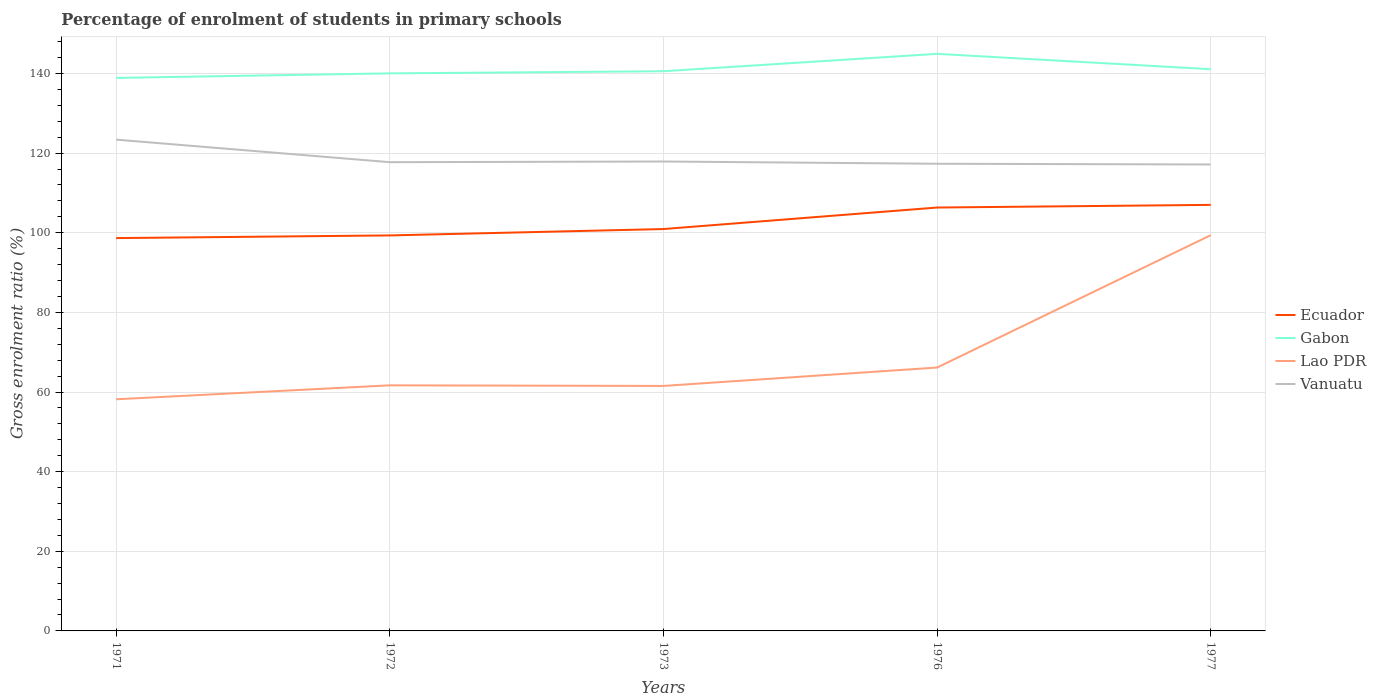How many different coloured lines are there?
Your answer should be very brief. 4. Across all years, what is the maximum percentage of students enrolled in primary schools in Ecuador?
Give a very brief answer. 98.66. What is the total percentage of students enrolled in primary schools in Gabon in the graph?
Offer a terse response. -6.04. What is the difference between the highest and the second highest percentage of students enrolled in primary schools in Vanuatu?
Offer a very short reply. 6.24. What is the difference between the highest and the lowest percentage of students enrolled in primary schools in Gabon?
Ensure brevity in your answer.  1. Is the percentage of students enrolled in primary schools in Gabon strictly greater than the percentage of students enrolled in primary schools in Vanuatu over the years?
Your answer should be very brief. No. How many years are there in the graph?
Make the answer very short. 5. What is the difference between two consecutive major ticks on the Y-axis?
Your response must be concise. 20. Does the graph contain grids?
Make the answer very short. Yes. What is the title of the graph?
Your answer should be compact. Percentage of enrolment of students in primary schools. What is the label or title of the X-axis?
Your response must be concise. Years. What is the label or title of the Y-axis?
Provide a succinct answer. Gross enrolment ratio (%). What is the Gross enrolment ratio (%) in Ecuador in 1971?
Offer a terse response. 98.66. What is the Gross enrolment ratio (%) in Gabon in 1971?
Your response must be concise. 138.89. What is the Gross enrolment ratio (%) in Lao PDR in 1971?
Provide a succinct answer. 58.17. What is the Gross enrolment ratio (%) in Vanuatu in 1971?
Your response must be concise. 123.39. What is the Gross enrolment ratio (%) of Ecuador in 1972?
Give a very brief answer. 99.33. What is the Gross enrolment ratio (%) of Gabon in 1972?
Your response must be concise. 140.03. What is the Gross enrolment ratio (%) of Lao PDR in 1972?
Your response must be concise. 61.68. What is the Gross enrolment ratio (%) in Vanuatu in 1972?
Ensure brevity in your answer.  117.72. What is the Gross enrolment ratio (%) in Ecuador in 1973?
Make the answer very short. 100.93. What is the Gross enrolment ratio (%) in Gabon in 1973?
Your answer should be compact. 140.56. What is the Gross enrolment ratio (%) in Lao PDR in 1973?
Your response must be concise. 61.53. What is the Gross enrolment ratio (%) of Vanuatu in 1973?
Offer a terse response. 117.89. What is the Gross enrolment ratio (%) of Ecuador in 1976?
Provide a succinct answer. 106.33. What is the Gross enrolment ratio (%) of Gabon in 1976?
Make the answer very short. 144.93. What is the Gross enrolment ratio (%) in Lao PDR in 1976?
Provide a short and direct response. 66.15. What is the Gross enrolment ratio (%) in Vanuatu in 1976?
Your answer should be very brief. 117.33. What is the Gross enrolment ratio (%) of Ecuador in 1977?
Offer a terse response. 107. What is the Gross enrolment ratio (%) in Gabon in 1977?
Provide a short and direct response. 141.07. What is the Gross enrolment ratio (%) of Lao PDR in 1977?
Offer a terse response. 99.39. What is the Gross enrolment ratio (%) in Vanuatu in 1977?
Give a very brief answer. 117.14. Across all years, what is the maximum Gross enrolment ratio (%) in Ecuador?
Offer a terse response. 107. Across all years, what is the maximum Gross enrolment ratio (%) in Gabon?
Provide a succinct answer. 144.93. Across all years, what is the maximum Gross enrolment ratio (%) in Lao PDR?
Your answer should be compact. 99.39. Across all years, what is the maximum Gross enrolment ratio (%) in Vanuatu?
Offer a terse response. 123.39. Across all years, what is the minimum Gross enrolment ratio (%) in Ecuador?
Keep it short and to the point. 98.66. Across all years, what is the minimum Gross enrolment ratio (%) in Gabon?
Offer a very short reply. 138.89. Across all years, what is the minimum Gross enrolment ratio (%) in Lao PDR?
Keep it short and to the point. 58.17. Across all years, what is the minimum Gross enrolment ratio (%) in Vanuatu?
Make the answer very short. 117.14. What is the total Gross enrolment ratio (%) in Ecuador in the graph?
Ensure brevity in your answer.  512.24. What is the total Gross enrolment ratio (%) in Gabon in the graph?
Your response must be concise. 705.48. What is the total Gross enrolment ratio (%) of Lao PDR in the graph?
Your response must be concise. 346.92. What is the total Gross enrolment ratio (%) of Vanuatu in the graph?
Offer a terse response. 593.47. What is the difference between the Gross enrolment ratio (%) in Ecuador in 1971 and that in 1972?
Offer a very short reply. -0.67. What is the difference between the Gross enrolment ratio (%) of Gabon in 1971 and that in 1972?
Provide a short and direct response. -1.14. What is the difference between the Gross enrolment ratio (%) of Lao PDR in 1971 and that in 1972?
Give a very brief answer. -3.51. What is the difference between the Gross enrolment ratio (%) in Vanuatu in 1971 and that in 1972?
Your answer should be very brief. 5.67. What is the difference between the Gross enrolment ratio (%) of Ecuador in 1971 and that in 1973?
Your answer should be very brief. -2.27. What is the difference between the Gross enrolment ratio (%) of Gabon in 1971 and that in 1973?
Provide a succinct answer. -1.68. What is the difference between the Gross enrolment ratio (%) of Lao PDR in 1971 and that in 1973?
Offer a very short reply. -3.35. What is the difference between the Gross enrolment ratio (%) in Vanuatu in 1971 and that in 1973?
Make the answer very short. 5.49. What is the difference between the Gross enrolment ratio (%) of Ecuador in 1971 and that in 1976?
Your response must be concise. -7.68. What is the difference between the Gross enrolment ratio (%) of Gabon in 1971 and that in 1976?
Give a very brief answer. -6.04. What is the difference between the Gross enrolment ratio (%) in Lao PDR in 1971 and that in 1976?
Keep it short and to the point. -7.97. What is the difference between the Gross enrolment ratio (%) of Vanuatu in 1971 and that in 1976?
Give a very brief answer. 6.06. What is the difference between the Gross enrolment ratio (%) in Ecuador in 1971 and that in 1977?
Offer a terse response. -8.34. What is the difference between the Gross enrolment ratio (%) of Gabon in 1971 and that in 1977?
Keep it short and to the point. -2.18. What is the difference between the Gross enrolment ratio (%) in Lao PDR in 1971 and that in 1977?
Keep it short and to the point. -41.21. What is the difference between the Gross enrolment ratio (%) in Vanuatu in 1971 and that in 1977?
Your answer should be very brief. 6.24. What is the difference between the Gross enrolment ratio (%) of Ecuador in 1972 and that in 1973?
Give a very brief answer. -1.6. What is the difference between the Gross enrolment ratio (%) of Gabon in 1972 and that in 1973?
Offer a very short reply. -0.54. What is the difference between the Gross enrolment ratio (%) in Lao PDR in 1972 and that in 1973?
Ensure brevity in your answer.  0.15. What is the difference between the Gross enrolment ratio (%) of Vanuatu in 1972 and that in 1973?
Offer a very short reply. -0.17. What is the difference between the Gross enrolment ratio (%) in Ecuador in 1972 and that in 1976?
Make the answer very short. -7.01. What is the difference between the Gross enrolment ratio (%) of Gabon in 1972 and that in 1976?
Provide a succinct answer. -4.9. What is the difference between the Gross enrolment ratio (%) in Lao PDR in 1972 and that in 1976?
Ensure brevity in your answer.  -4.47. What is the difference between the Gross enrolment ratio (%) in Vanuatu in 1972 and that in 1976?
Offer a very short reply. 0.39. What is the difference between the Gross enrolment ratio (%) in Ecuador in 1972 and that in 1977?
Offer a terse response. -7.67. What is the difference between the Gross enrolment ratio (%) of Gabon in 1972 and that in 1977?
Your answer should be compact. -1.04. What is the difference between the Gross enrolment ratio (%) of Lao PDR in 1972 and that in 1977?
Your answer should be very brief. -37.71. What is the difference between the Gross enrolment ratio (%) of Vanuatu in 1972 and that in 1977?
Provide a short and direct response. 0.57. What is the difference between the Gross enrolment ratio (%) of Ecuador in 1973 and that in 1976?
Ensure brevity in your answer.  -5.4. What is the difference between the Gross enrolment ratio (%) of Gabon in 1973 and that in 1976?
Your answer should be very brief. -4.37. What is the difference between the Gross enrolment ratio (%) in Lao PDR in 1973 and that in 1976?
Your answer should be very brief. -4.62. What is the difference between the Gross enrolment ratio (%) of Vanuatu in 1973 and that in 1976?
Keep it short and to the point. 0.57. What is the difference between the Gross enrolment ratio (%) of Ecuador in 1973 and that in 1977?
Keep it short and to the point. -6.07. What is the difference between the Gross enrolment ratio (%) in Gabon in 1973 and that in 1977?
Offer a very short reply. -0.51. What is the difference between the Gross enrolment ratio (%) in Lao PDR in 1973 and that in 1977?
Provide a short and direct response. -37.86. What is the difference between the Gross enrolment ratio (%) of Vanuatu in 1973 and that in 1977?
Provide a short and direct response. 0.75. What is the difference between the Gross enrolment ratio (%) of Ecuador in 1976 and that in 1977?
Offer a terse response. -0.67. What is the difference between the Gross enrolment ratio (%) of Gabon in 1976 and that in 1977?
Give a very brief answer. 3.86. What is the difference between the Gross enrolment ratio (%) in Lao PDR in 1976 and that in 1977?
Offer a terse response. -33.24. What is the difference between the Gross enrolment ratio (%) of Vanuatu in 1976 and that in 1977?
Your answer should be very brief. 0.18. What is the difference between the Gross enrolment ratio (%) in Ecuador in 1971 and the Gross enrolment ratio (%) in Gabon in 1972?
Ensure brevity in your answer.  -41.37. What is the difference between the Gross enrolment ratio (%) of Ecuador in 1971 and the Gross enrolment ratio (%) of Lao PDR in 1972?
Provide a succinct answer. 36.98. What is the difference between the Gross enrolment ratio (%) of Ecuador in 1971 and the Gross enrolment ratio (%) of Vanuatu in 1972?
Provide a succinct answer. -19.06. What is the difference between the Gross enrolment ratio (%) in Gabon in 1971 and the Gross enrolment ratio (%) in Lao PDR in 1972?
Provide a short and direct response. 77.21. What is the difference between the Gross enrolment ratio (%) in Gabon in 1971 and the Gross enrolment ratio (%) in Vanuatu in 1972?
Keep it short and to the point. 21.17. What is the difference between the Gross enrolment ratio (%) of Lao PDR in 1971 and the Gross enrolment ratio (%) of Vanuatu in 1972?
Give a very brief answer. -59.54. What is the difference between the Gross enrolment ratio (%) of Ecuador in 1971 and the Gross enrolment ratio (%) of Gabon in 1973?
Your answer should be compact. -41.91. What is the difference between the Gross enrolment ratio (%) of Ecuador in 1971 and the Gross enrolment ratio (%) of Lao PDR in 1973?
Provide a short and direct response. 37.13. What is the difference between the Gross enrolment ratio (%) in Ecuador in 1971 and the Gross enrolment ratio (%) in Vanuatu in 1973?
Keep it short and to the point. -19.24. What is the difference between the Gross enrolment ratio (%) in Gabon in 1971 and the Gross enrolment ratio (%) in Lao PDR in 1973?
Ensure brevity in your answer.  77.36. What is the difference between the Gross enrolment ratio (%) in Gabon in 1971 and the Gross enrolment ratio (%) in Vanuatu in 1973?
Offer a very short reply. 20.99. What is the difference between the Gross enrolment ratio (%) in Lao PDR in 1971 and the Gross enrolment ratio (%) in Vanuatu in 1973?
Give a very brief answer. -59.72. What is the difference between the Gross enrolment ratio (%) of Ecuador in 1971 and the Gross enrolment ratio (%) of Gabon in 1976?
Your response must be concise. -46.27. What is the difference between the Gross enrolment ratio (%) of Ecuador in 1971 and the Gross enrolment ratio (%) of Lao PDR in 1976?
Give a very brief answer. 32.51. What is the difference between the Gross enrolment ratio (%) in Ecuador in 1971 and the Gross enrolment ratio (%) in Vanuatu in 1976?
Your answer should be compact. -18.67. What is the difference between the Gross enrolment ratio (%) in Gabon in 1971 and the Gross enrolment ratio (%) in Lao PDR in 1976?
Offer a terse response. 72.74. What is the difference between the Gross enrolment ratio (%) of Gabon in 1971 and the Gross enrolment ratio (%) of Vanuatu in 1976?
Provide a short and direct response. 21.56. What is the difference between the Gross enrolment ratio (%) in Lao PDR in 1971 and the Gross enrolment ratio (%) in Vanuatu in 1976?
Your answer should be very brief. -59.15. What is the difference between the Gross enrolment ratio (%) in Ecuador in 1971 and the Gross enrolment ratio (%) in Gabon in 1977?
Your response must be concise. -42.42. What is the difference between the Gross enrolment ratio (%) of Ecuador in 1971 and the Gross enrolment ratio (%) of Lao PDR in 1977?
Ensure brevity in your answer.  -0.73. What is the difference between the Gross enrolment ratio (%) in Ecuador in 1971 and the Gross enrolment ratio (%) in Vanuatu in 1977?
Make the answer very short. -18.49. What is the difference between the Gross enrolment ratio (%) of Gabon in 1971 and the Gross enrolment ratio (%) of Lao PDR in 1977?
Give a very brief answer. 39.5. What is the difference between the Gross enrolment ratio (%) of Gabon in 1971 and the Gross enrolment ratio (%) of Vanuatu in 1977?
Provide a succinct answer. 21.74. What is the difference between the Gross enrolment ratio (%) of Lao PDR in 1971 and the Gross enrolment ratio (%) of Vanuatu in 1977?
Your answer should be compact. -58.97. What is the difference between the Gross enrolment ratio (%) of Ecuador in 1972 and the Gross enrolment ratio (%) of Gabon in 1973?
Keep it short and to the point. -41.24. What is the difference between the Gross enrolment ratio (%) in Ecuador in 1972 and the Gross enrolment ratio (%) in Lao PDR in 1973?
Keep it short and to the point. 37.8. What is the difference between the Gross enrolment ratio (%) in Ecuador in 1972 and the Gross enrolment ratio (%) in Vanuatu in 1973?
Make the answer very short. -18.57. What is the difference between the Gross enrolment ratio (%) in Gabon in 1972 and the Gross enrolment ratio (%) in Lao PDR in 1973?
Provide a succinct answer. 78.5. What is the difference between the Gross enrolment ratio (%) of Gabon in 1972 and the Gross enrolment ratio (%) of Vanuatu in 1973?
Give a very brief answer. 22.13. What is the difference between the Gross enrolment ratio (%) in Lao PDR in 1972 and the Gross enrolment ratio (%) in Vanuatu in 1973?
Ensure brevity in your answer.  -56.21. What is the difference between the Gross enrolment ratio (%) in Ecuador in 1972 and the Gross enrolment ratio (%) in Gabon in 1976?
Ensure brevity in your answer.  -45.6. What is the difference between the Gross enrolment ratio (%) of Ecuador in 1972 and the Gross enrolment ratio (%) of Lao PDR in 1976?
Keep it short and to the point. 33.18. What is the difference between the Gross enrolment ratio (%) of Ecuador in 1972 and the Gross enrolment ratio (%) of Vanuatu in 1976?
Give a very brief answer. -18. What is the difference between the Gross enrolment ratio (%) in Gabon in 1972 and the Gross enrolment ratio (%) in Lao PDR in 1976?
Your response must be concise. 73.88. What is the difference between the Gross enrolment ratio (%) of Gabon in 1972 and the Gross enrolment ratio (%) of Vanuatu in 1976?
Ensure brevity in your answer.  22.7. What is the difference between the Gross enrolment ratio (%) in Lao PDR in 1972 and the Gross enrolment ratio (%) in Vanuatu in 1976?
Ensure brevity in your answer.  -55.65. What is the difference between the Gross enrolment ratio (%) in Ecuador in 1972 and the Gross enrolment ratio (%) in Gabon in 1977?
Keep it short and to the point. -41.75. What is the difference between the Gross enrolment ratio (%) of Ecuador in 1972 and the Gross enrolment ratio (%) of Lao PDR in 1977?
Make the answer very short. -0.06. What is the difference between the Gross enrolment ratio (%) of Ecuador in 1972 and the Gross enrolment ratio (%) of Vanuatu in 1977?
Provide a succinct answer. -17.82. What is the difference between the Gross enrolment ratio (%) of Gabon in 1972 and the Gross enrolment ratio (%) of Lao PDR in 1977?
Your answer should be compact. 40.64. What is the difference between the Gross enrolment ratio (%) of Gabon in 1972 and the Gross enrolment ratio (%) of Vanuatu in 1977?
Provide a short and direct response. 22.88. What is the difference between the Gross enrolment ratio (%) of Lao PDR in 1972 and the Gross enrolment ratio (%) of Vanuatu in 1977?
Offer a terse response. -55.46. What is the difference between the Gross enrolment ratio (%) of Ecuador in 1973 and the Gross enrolment ratio (%) of Gabon in 1976?
Ensure brevity in your answer.  -44. What is the difference between the Gross enrolment ratio (%) in Ecuador in 1973 and the Gross enrolment ratio (%) in Lao PDR in 1976?
Offer a very short reply. 34.78. What is the difference between the Gross enrolment ratio (%) of Ecuador in 1973 and the Gross enrolment ratio (%) of Vanuatu in 1976?
Your answer should be compact. -16.4. What is the difference between the Gross enrolment ratio (%) of Gabon in 1973 and the Gross enrolment ratio (%) of Lao PDR in 1976?
Make the answer very short. 74.42. What is the difference between the Gross enrolment ratio (%) in Gabon in 1973 and the Gross enrolment ratio (%) in Vanuatu in 1976?
Ensure brevity in your answer.  23.24. What is the difference between the Gross enrolment ratio (%) in Lao PDR in 1973 and the Gross enrolment ratio (%) in Vanuatu in 1976?
Give a very brief answer. -55.8. What is the difference between the Gross enrolment ratio (%) in Ecuador in 1973 and the Gross enrolment ratio (%) in Gabon in 1977?
Give a very brief answer. -40.14. What is the difference between the Gross enrolment ratio (%) in Ecuador in 1973 and the Gross enrolment ratio (%) in Lao PDR in 1977?
Keep it short and to the point. 1.54. What is the difference between the Gross enrolment ratio (%) in Ecuador in 1973 and the Gross enrolment ratio (%) in Vanuatu in 1977?
Offer a terse response. -16.21. What is the difference between the Gross enrolment ratio (%) of Gabon in 1973 and the Gross enrolment ratio (%) of Lao PDR in 1977?
Offer a very short reply. 41.18. What is the difference between the Gross enrolment ratio (%) of Gabon in 1973 and the Gross enrolment ratio (%) of Vanuatu in 1977?
Give a very brief answer. 23.42. What is the difference between the Gross enrolment ratio (%) of Lao PDR in 1973 and the Gross enrolment ratio (%) of Vanuatu in 1977?
Give a very brief answer. -55.62. What is the difference between the Gross enrolment ratio (%) of Ecuador in 1976 and the Gross enrolment ratio (%) of Gabon in 1977?
Make the answer very short. -34.74. What is the difference between the Gross enrolment ratio (%) of Ecuador in 1976 and the Gross enrolment ratio (%) of Lao PDR in 1977?
Offer a very short reply. 6.94. What is the difference between the Gross enrolment ratio (%) in Ecuador in 1976 and the Gross enrolment ratio (%) in Vanuatu in 1977?
Your response must be concise. -10.81. What is the difference between the Gross enrolment ratio (%) of Gabon in 1976 and the Gross enrolment ratio (%) of Lao PDR in 1977?
Your response must be concise. 45.54. What is the difference between the Gross enrolment ratio (%) of Gabon in 1976 and the Gross enrolment ratio (%) of Vanuatu in 1977?
Your response must be concise. 27.78. What is the difference between the Gross enrolment ratio (%) in Lao PDR in 1976 and the Gross enrolment ratio (%) in Vanuatu in 1977?
Give a very brief answer. -51. What is the average Gross enrolment ratio (%) of Ecuador per year?
Offer a very short reply. 102.45. What is the average Gross enrolment ratio (%) in Gabon per year?
Offer a very short reply. 141.1. What is the average Gross enrolment ratio (%) in Lao PDR per year?
Give a very brief answer. 69.38. What is the average Gross enrolment ratio (%) of Vanuatu per year?
Make the answer very short. 118.69. In the year 1971, what is the difference between the Gross enrolment ratio (%) of Ecuador and Gross enrolment ratio (%) of Gabon?
Keep it short and to the point. -40.23. In the year 1971, what is the difference between the Gross enrolment ratio (%) in Ecuador and Gross enrolment ratio (%) in Lao PDR?
Give a very brief answer. 40.48. In the year 1971, what is the difference between the Gross enrolment ratio (%) of Ecuador and Gross enrolment ratio (%) of Vanuatu?
Make the answer very short. -24.73. In the year 1971, what is the difference between the Gross enrolment ratio (%) in Gabon and Gross enrolment ratio (%) in Lao PDR?
Your answer should be compact. 80.71. In the year 1971, what is the difference between the Gross enrolment ratio (%) in Gabon and Gross enrolment ratio (%) in Vanuatu?
Give a very brief answer. 15.5. In the year 1971, what is the difference between the Gross enrolment ratio (%) of Lao PDR and Gross enrolment ratio (%) of Vanuatu?
Give a very brief answer. -65.21. In the year 1972, what is the difference between the Gross enrolment ratio (%) in Ecuador and Gross enrolment ratio (%) in Gabon?
Ensure brevity in your answer.  -40.7. In the year 1972, what is the difference between the Gross enrolment ratio (%) of Ecuador and Gross enrolment ratio (%) of Lao PDR?
Give a very brief answer. 37.65. In the year 1972, what is the difference between the Gross enrolment ratio (%) in Ecuador and Gross enrolment ratio (%) in Vanuatu?
Offer a terse response. -18.39. In the year 1972, what is the difference between the Gross enrolment ratio (%) of Gabon and Gross enrolment ratio (%) of Lao PDR?
Provide a short and direct response. 78.35. In the year 1972, what is the difference between the Gross enrolment ratio (%) in Gabon and Gross enrolment ratio (%) in Vanuatu?
Your response must be concise. 22.31. In the year 1972, what is the difference between the Gross enrolment ratio (%) in Lao PDR and Gross enrolment ratio (%) in Vanuatu?
Your response must be concise. -56.04. In the year 1973, what is the difference between the Gross enrolment ratio (%) in Ecuador and Gross enrolment ratio (%) in Gabon?
Provide a short and direct response. -39.63. In the year 1973, what is the difference between the Gross enrolment ratio (%) in Ecuador and Gross enrolment ratio (%) in Lao PDR?
Offer a terse response. 39.4. In the year 1973, what is the difference between the Gross enrolment ratio (%) in Ecuador and Gross enrolment ratio (%) in Vanuatu?
Your answer should be very brief. -16.96. In the year 1973, what is the difference between the Gross enrolment ratio (%) of Gabon and Gross enrolment ratio (%) of Lao PDR?
Offer a very short reply. 79.04. In the year 1973, what is the difference between the Gross enrolment ratio (%) in Gabon and Gross enrolment ratio (%) in Vanuatu?
Provide a succinct answer. 22.67. In the year 1973, what is the difference between the Gross enrolment ratio (%) in Lao PDR and Gross enrolment ratio (%) in Vanuatu?
Ensure brevity in your answer.  -56.37. In the year 1976, what is the difference between the Gross enrolment ratio (%) in Ecuador and Gross enrolment ratio (%) in Gabon?
Offer a terse response. -38.6. In the year 1976, what is the difference between the Gross enrolment ratio (%) in Ecuador and Gross enrolment ratio (%) in Lao PDR?
Your answer should be compact. 40.18. In the year 1976, what is the difference between the Gross enrolment ratio (%) in Ecuador and Gross enrolment ratio (%) in Vanuatu?
Ensure brevity in your answer.  -11. In the year 1976, what is the difference between the Gross enrolment ratio (%) in Gabon and Gross enrolment ratio (%) in Lao PDR?
Provide a short and direct response. 78.78. In the year 1976, what is the difference between the Gross enrolment ratio (%) in Gabon and Gross enrolment ratio (%) in Vanuatu?
Offer a terse response. 27.6. In the year 1976, what is the difference between the Gross enrolment ratio (%) of Lao PDR and Gross enrolment ratio (%) of Vanuatu?
Offer a terse response. -51.18. In the year 1977, what is the difference between the Gross enrolment ratio (%) of Ecuador and Gross enrolment ratio (%) of Gabon?
Your response must be concise. -34.07. In the year 1977, what is the difference between the Gross enrolment ratio (%) in Ecuador and Gross enrolment ratio (%) in Lao PDR?
Provide a short and direct response. 7.61. In the year 1977, what is the difference between the Gross enrolment ratio (%) of Ecuador and Gross enrolment ratio (%) of Vanuatu?
Provide a succinct answer. -10.15. In the year 1977, what is the difference between the Gross enrolment ratio (%) of Gabon and Gross enrolment ratio (%) of Lao PDR?
Provide a short and direct response. 41.68. In the year 1977, what is the difference between the Gross enrolment ratio (%) of Gabon and Gross enrolment ratio (%) of Vanuatu?
Give a very brief answer. 23.93. In the year 1977, what is the difference between the Gross enrolment ratio (%) of Lao PDR and Gross enrolment ratio (%) of Vanuatu?
Your answer should be compact. -17.76. What is the ratio of the Gross enrolment ratio (%) in Gabon in 1971 to that in 1972?
Offer a terse response. 0.99. What is the ratio of the Gross enrolment ratio (%) in Lao PDR in 1971 to that in 1972?
Provide a short and direct response. 0.94. What is the ratio of the Gross enrolment ratio (%) in Vanuatu in 1971 to that in 1972?
Your answer should be compact. 1.05. What is the ratio of the Gross enrolment ratio (%) in Ecuador in 1971 to that in 1973?
Provide a short and direct response. 0.98. What is the ratio of the Gross enrolment ratio (%) in Lao PDR in 1971 to that in 1973?
Your answer should be very brief. 0.95. What is the ratio of the Gross enrolment ratio (%) in Vanuatu in 1971 to that in 1973?
Provide a succinct answer. 1.05. What is the ratio of the Gross enrolment ratio (%) in Ecuador in 1971 to that in 1976?
Give a very brief answer. 0.93. What is the ratio of the Gross enrolment ratio (%) in Gabon in 1971 to that in 1976?
Provide a succinct answer. 0.96. What is the ratio of the Gross enrolment ratio (%) in Lao PDR in 1971 to that in 1976?
Ensure brevity in your answer.  0.88. What is the ratio of the Gross enrolment ratio (%) in Vanuatu in 1971 to that in 1976?
Make the answer very short. 1.05. What is the ratio of the Gross enrolment ratio (%) of Ecuador in 1971 to that in 1977?
Provide a succinct answer. 0.92. What is the ratio of the Gross enrolment ratio (%) in Gabon in 1971 to that in 1977?
Offer a very short reply. 0.98. What is the ratio of the Gross enrolment ratio (%) in Lao PDR in 1971 to that in 1977?
Your answer should be compact. 0.59. What is the ratio of the Gross enrolment ratio (%) in Vanuatu in 1971 to that in 1977?
Provide a short and direct response. 1.05. What is the ratio of the Gross enrolment ratio (%) of Ecuador in 1972 to that in 1973?
Offer a very short reply. 0.98. What is the ratio of the Gross enrolment ratio (%) in Gabon in 1972 to that in 1973?
Your response must be concise. 1. What is the ratio of the Gross enrolment ratio (%) in Ecuador in 1972 to that in 1976?
Your answer should be very brief. 0.93. What is the ratio of the Gross enrolment ratio (%) in Gabon in 1972 to that in 1976?
Ensure brevity in your answer.  0.97. What is the ratio of the Gross enrolment ratio (%) in Lao PDR in 1972 to that in 1976?
Your answer should be compact. 0.93. What is the ratio of the Gross enrolment ratio (%) in Ecuador in 1972 to that in 1977?
Offer a terse response. 0.93. What is the ratio of the Gross enrolment ratio (%) of Lao PDR in 1972 to that in 1977?
Your answer should be compact. 0.62. What is the ratio of the Gross enrolment ratio (%) of Vanuatu in 1972 to that in 1977?
Your answer should be very brief. 1. What is the ratio of the Gross enrolment ratio (%) of Ecuador in 1973 to that in 1976?
Keep it short and to the point. 0.95. What is the ratio of the Gross enrolment ratio (%) of Gabon in 1973 to that in 1976?
Provide a short and direct response. 0.97. What is the ratio of the Gross enrolment ratio (%) in Lao PDR in 1973 to that in 1976?
Give a very brief answer. 0.93. What is the ratio of the Gross enrolment ratio (%) in Vanuatu in 1973 to that in 1976?
Keep it short and to the point. 1. What is the ratio of the Gross enrolment ratio (%) in Ecuador in 1973 to that in 1977?
Provide a succinct answer. 0.94. What is the ratio of the Gross enrolment ratio (%) in Lao PDR in 1973 to that in 1977?
Provide a short and direct response. 0.62. What is the ratio of the Gross enrolment ratio (%) in Vanuatu in 1973 to that in 1977?
Give a very brief answer. 1.01. What is the ratio of the Gross enrolment ratio (%) of Gabon in 1976 to that in 1977?
Ensure brevity in your answer.  1.03. What is the ratio of the Gross enrolment ratio (%) of Lao PDR in 1976 to that in 1977?
Keep it short and to the point. 0.67. What is the difference between the highest and the second highest Gross enrolment ratio (%) of Ecuador?
Your answer should be compact. 0.67. What is the difference between the highest and the second highest Gross enrolment ratio (%) of Gabon?
Keep it short and to the point. 3.86. What is the difference between the highest and the second highest Gross enrolment ratio (%) in Lao PDR?
Your answer should be compact. 33.24. What is the difference between the highest and the second highest Gross enrolment ratio (%) in Vanuatu?
Offer a very short reply. 5.49. What is the difference between the highest and the lowest Gross enrolment ratio (%) of Ecuador?
Offer a terse response. 8.34. What is the difference between the highest and the lowest Gross enrolment ratio (%) in Gabon?
Keep it short and to the point. 6.04. What is the difference between the highest and the lowest Gross enrolment ratio (%) in Lao PDR?
Give a very brief answer. 41.21. What is the difference between the highest and the lowest Gross enrolment ratio (%) in Vanuatu?
Make the answer very short. 6.24. 